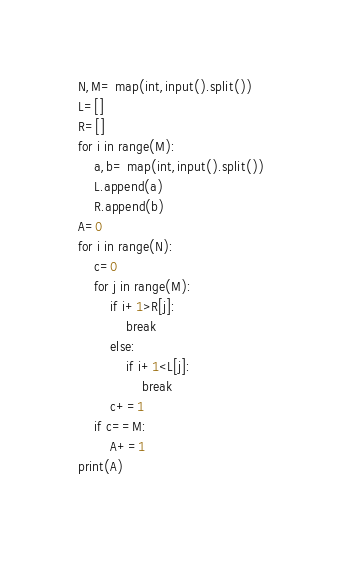<code> <loc_0><loc_0><loc_500><loc_500><_Python_>N,M= map(int,input().split())
L=[]
R=[]
for i in range(M):
	a,b= map(int,input().split())
	L.append(a)
	R.append(b)
A=0
for i in range(N):
	c=0
	for j in range(M):
		if i+1>R[j]:
			break
		else:
			if i+1<L[j]:
				break
		c+=1
	if c==M:
		A+=1
print(A)
		</code> 